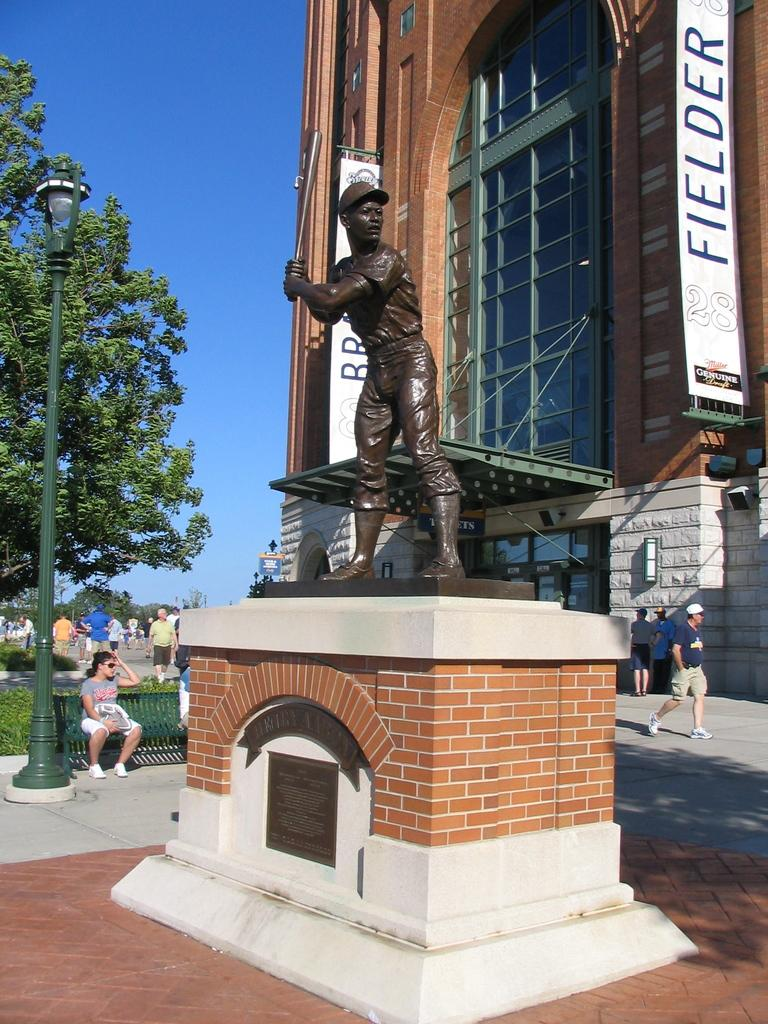<image>
Give a short and clear explanation of the subsequent image. A bronze statue of a boy with a baseball bat in front of the Fiedler building. 